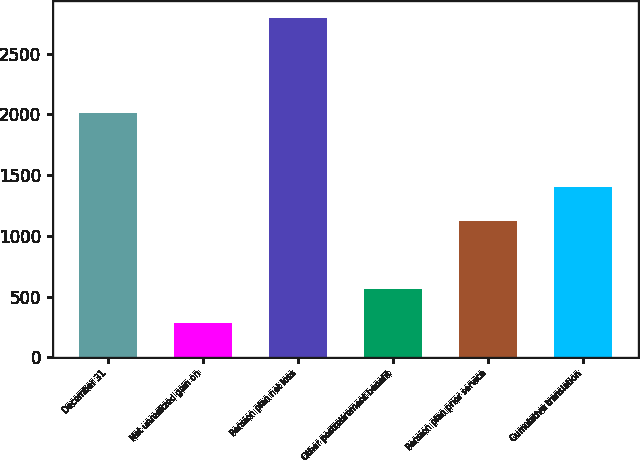Convert chart to OTSL. <chart><loc_0><loc_0><loc_500><loc_500><bar_chart><fcel>December 31<fcel>Net unrealized gain on<fcel>Pension plan net loss<fcel>Other postretirement benefit<fcel>Pension plan prior service<fcel>Cumulative translation<nl><fcel>2011<fcel>282.9<fcel>2793<fcel>561.8<fcel>1119.6<fcel>1398.5<nl></chart> 